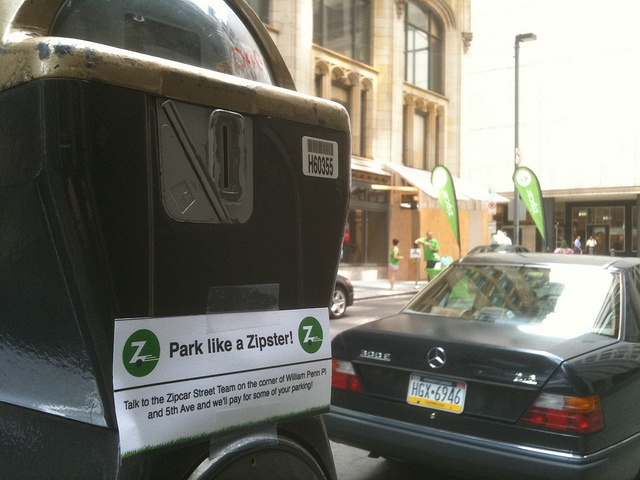Describe the objects in this image and their specific colors. I can see parking meter in tan, black, gray, and darkgray tones, car in tan, black, gray, white, and darkgray tones, car in tan, gray, darkgray, ivory, and black tones, people in tan, green, olive, khaki, and gray tones, and car in tan, darkgray, gray, and lightgray tones in this image. 